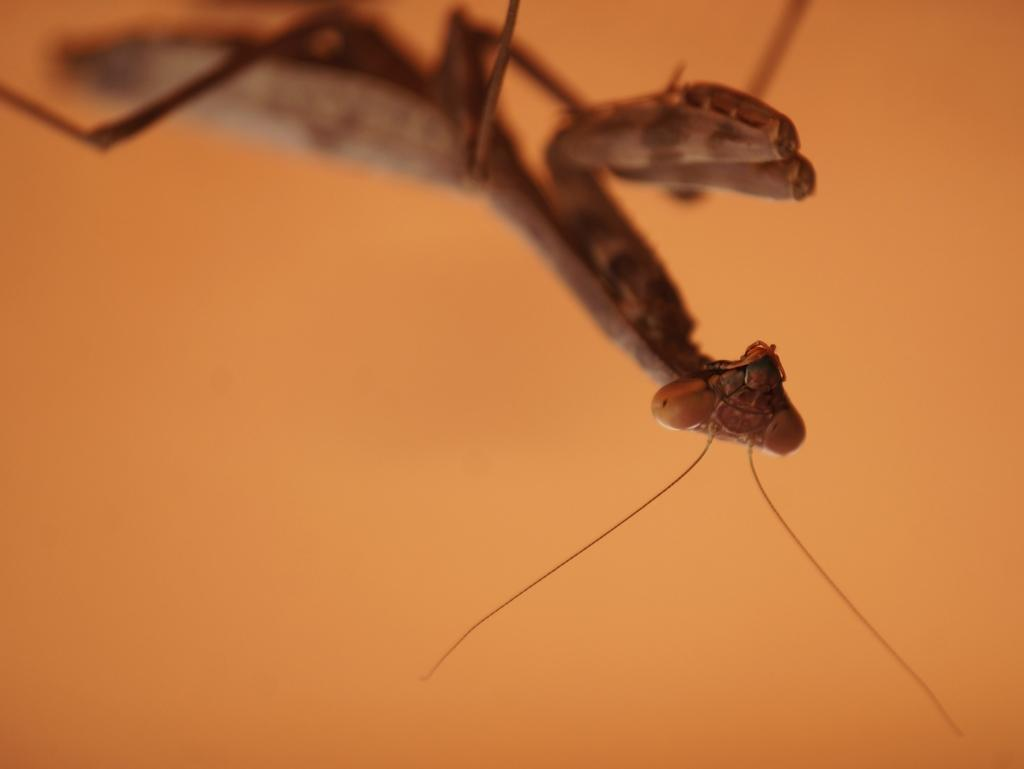What type of animal is in the image? There is a grasshopper in the image. What color is the grasshopper? The grasshopper is brown in color. What can be seen in the background of the image? The background of the image is orange. What type of house does the goose live in within the image? There is no goose or house present in the image; it features a grasshopper against an orange background. 